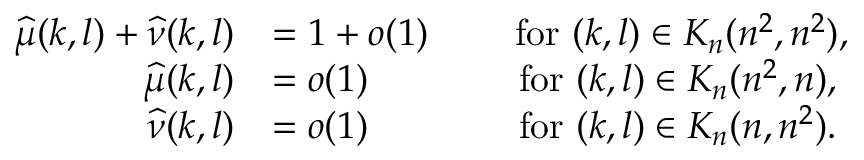<formula> <loc_0><loc_0><loc_500><loc_500>\begin{array} { r l } { \widehat { \mu } ( k , l ) + \widehat { \nu } ( k , l ) } & { = 1 + o ( 1 ) \, \quad f o r ( k , l ) \in K _ { n } ( n ^ { 2 } , n ^ { 2 } ) , } \\ { \widehat { \mu } ( k , l ) } & { = o ( 1 ) \quad f o r ( k , l ) \in K _ { n } ( n ^ { 2 } , n ) , } \\ { \widehat { \nu } ( k , l ) } & { = o ( 1 ) \quad f o r ( k , l ) \in K _ { n } ( n , n ^ { 2 } ) . } \end{array}</formula> 